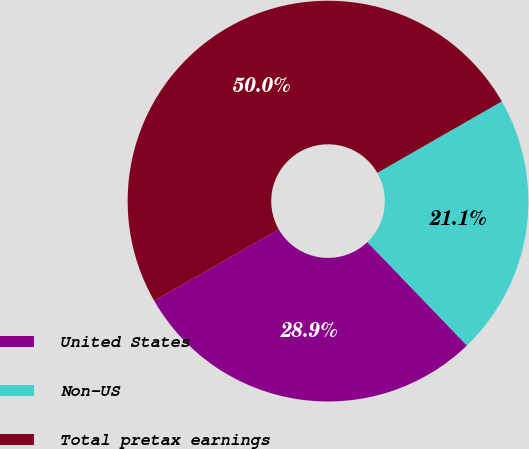<chart> <loc_0><loc_0><loc_500><loc_500><pie_chart><fcel>United States<fcel>Non-US<fcel>Total pretax earnings<nl><fcel>28.91%<fcel>21.09%<fcel>50.0%<nl></chart> 